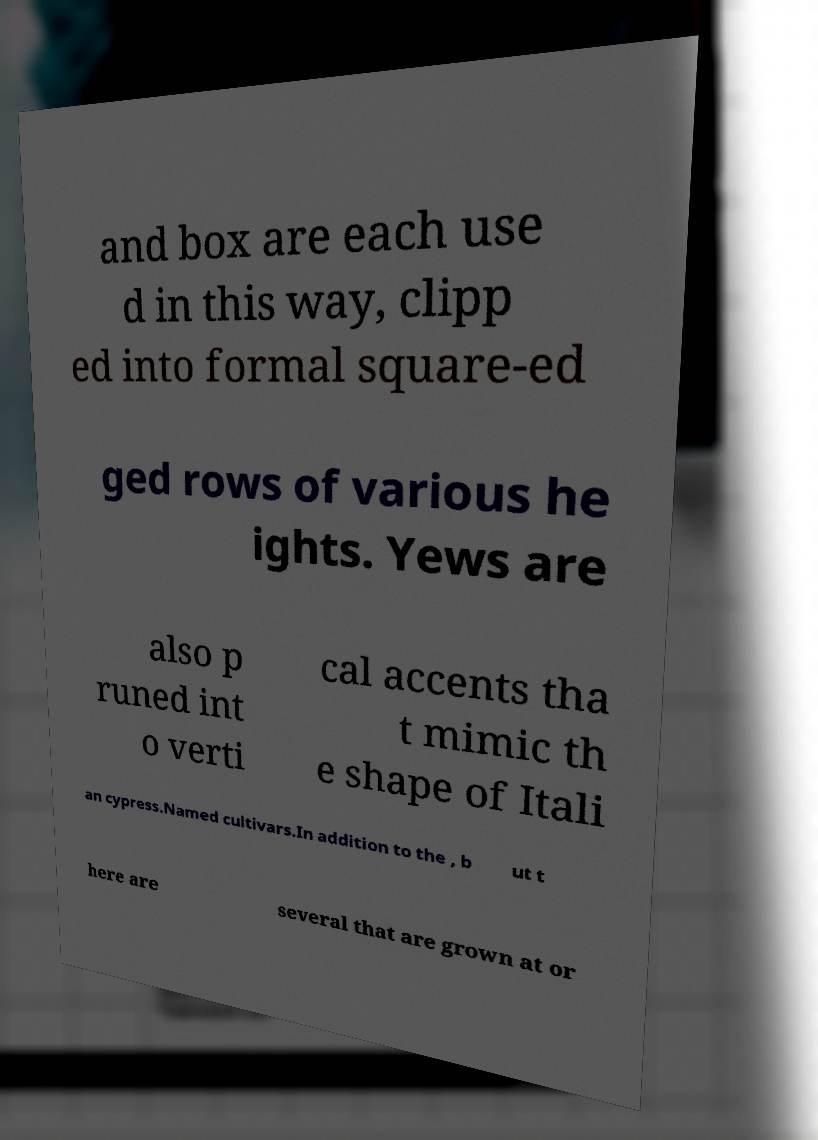Could you assist in decoding the text presented in this image and type it out clearly? and box are each use d in this way, clipp ed into formal square-ed ged rows of various he ights. Yews are also p runed int o verti cal accents tha t mimic th e shape of Itali an cypress.Named cultivars.In addition to the , b ut t here are several that are grown at or 